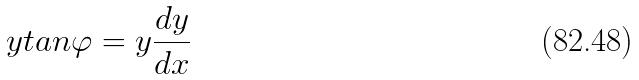Convert formula to latex. <formula><loc_0><loc_0><loc_500><loc_500>y t a n \varphi = y \frac { d y } { d x }</formula> 